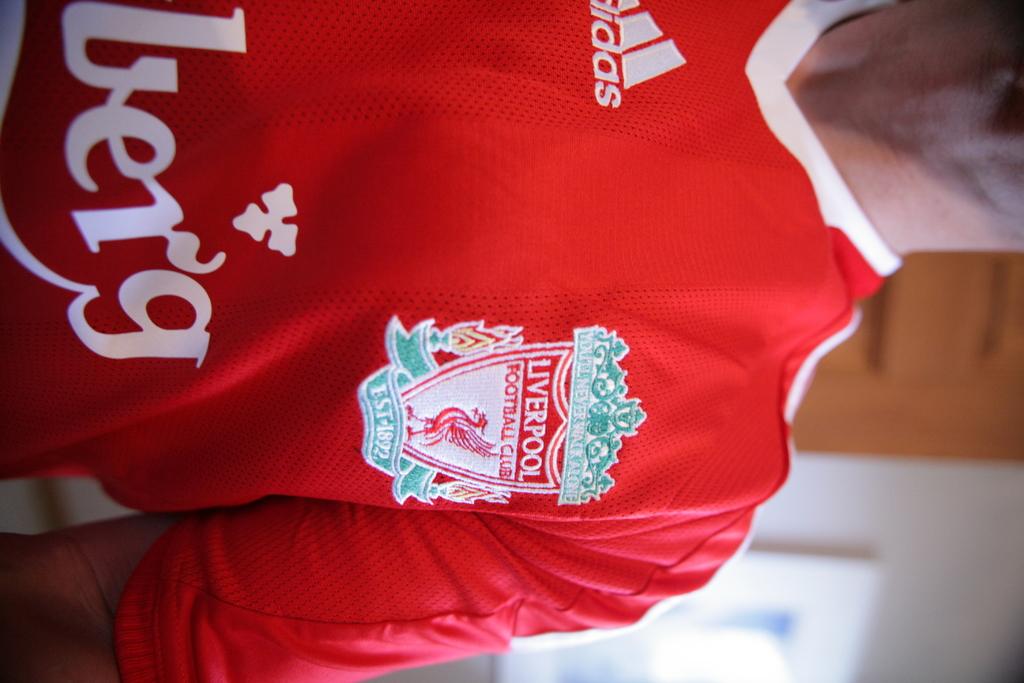Is this man a fan of football?
Provide a short and direct response. Yes. What brand is the jersey?
Your response must be concise. Adidas. 